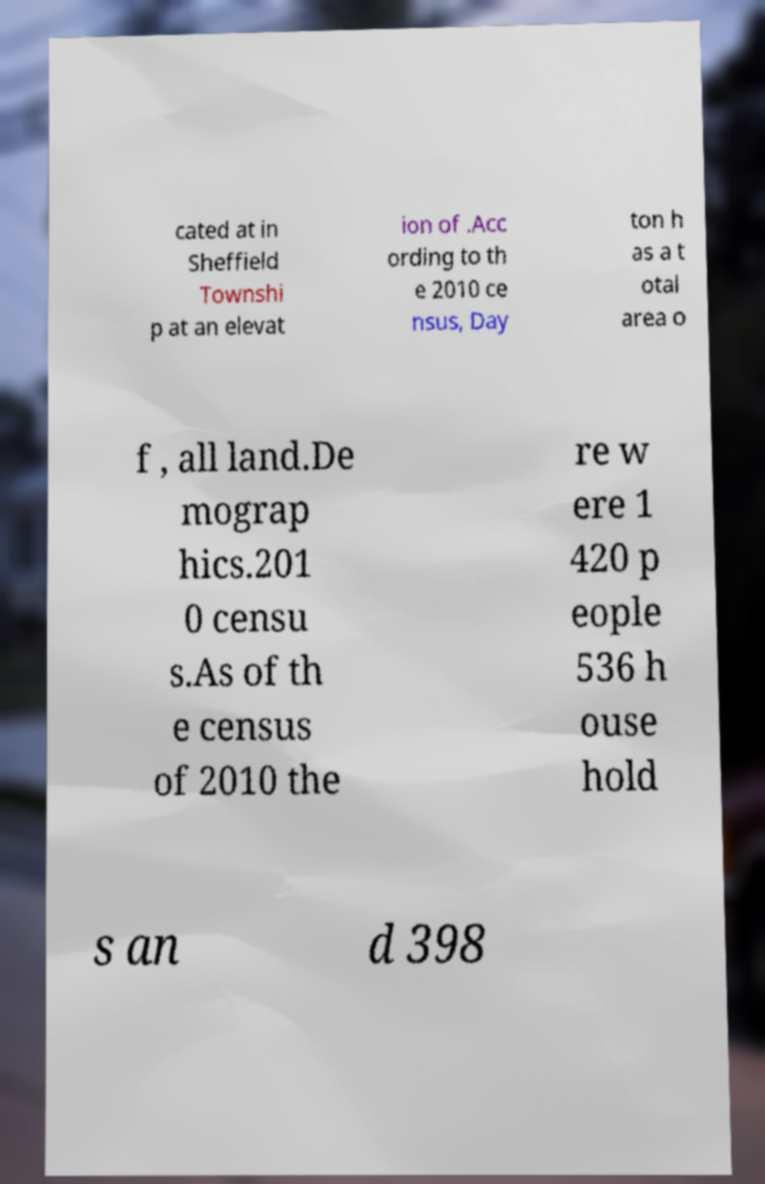Can you read and provide the text displayed in the image?This photo seems to have some interesting text. Can you extract and type it out for me? cated at in Sheffield Townshi p at an elevat ion of .Acc ording to th e 2010 ce nsus, Day ton h as a t otal area o f , all land.De mograp hics.201 0 censu s.As of th e census of 2010 the re w ere 1 420 p eople 536 h ouse hold s an d 398 